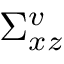Convert formula to latex. <formula><loc_0><loc_0><loc_500><loc_500>\Sigma _ { x z } ^ { v }</formula> 